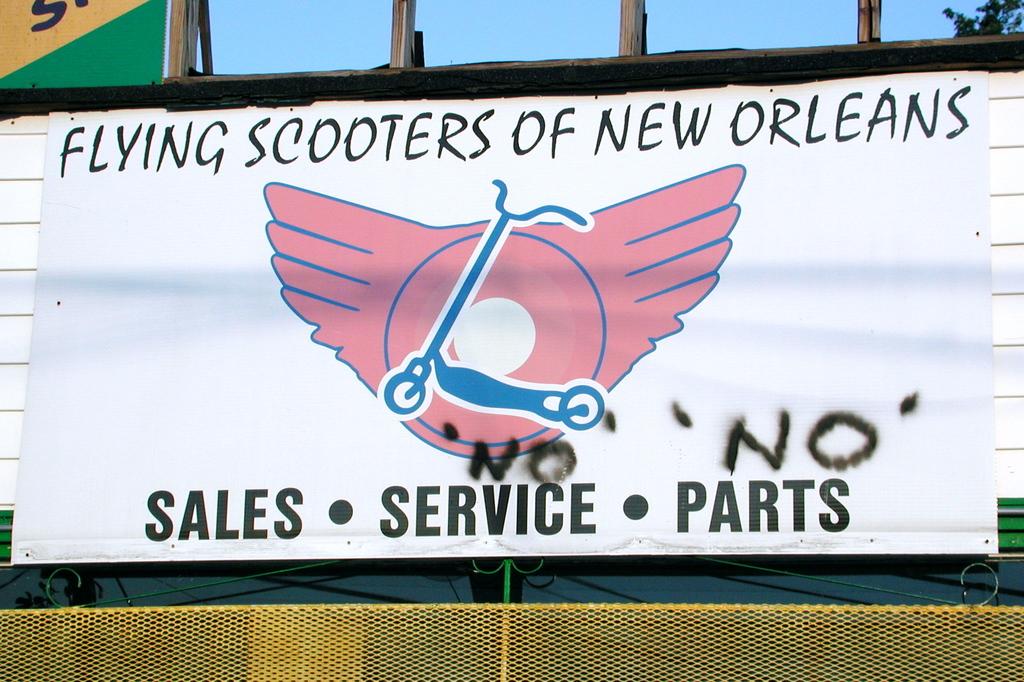What company is advertised here?
Your answer should be compact. Flying scooters of new orleans. 